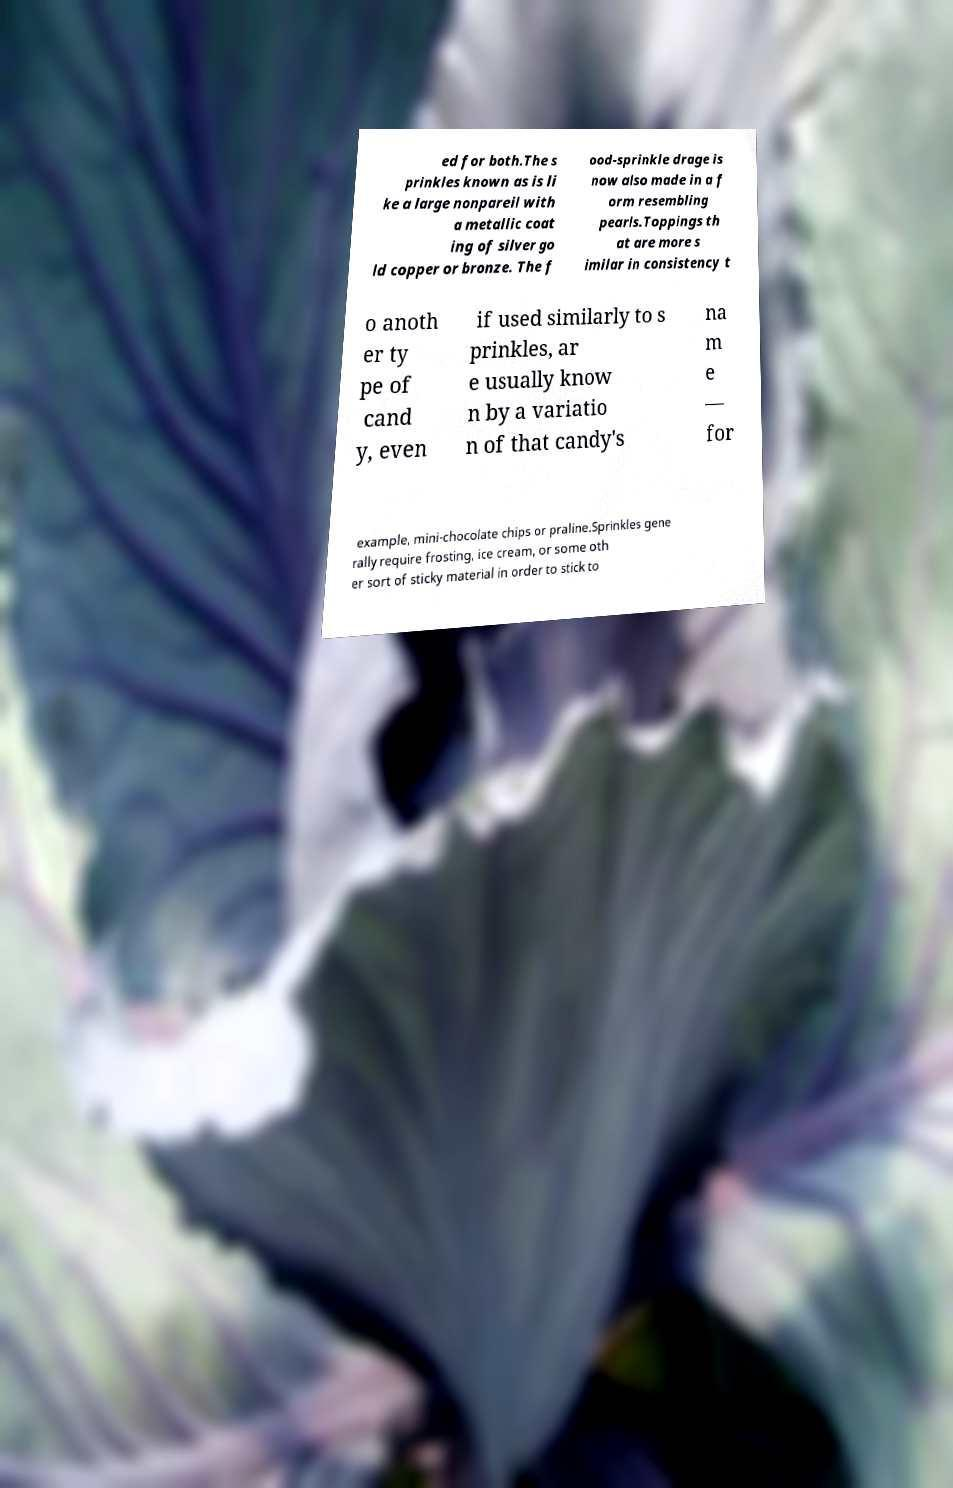Could you extract and type out the text from this image? ed for both.The s prinkles known as is li ke a large nonpareil with a metallic coat ing of silver go ld copper or bronze. The f ood-sprinkle drage is now also made in a f orm resembling pearls.Toppings th at are more s imilar in consistency t o anoth er ty pe of cand y, even if used similarly to s prinkles, ar e usually know n by a variatio n of that candy's na m e — for example, mini-chocolate chips or praline.Sprinkles gene rally require frosting, ice cream, or some oth er sort of sticky material in order to stick to 